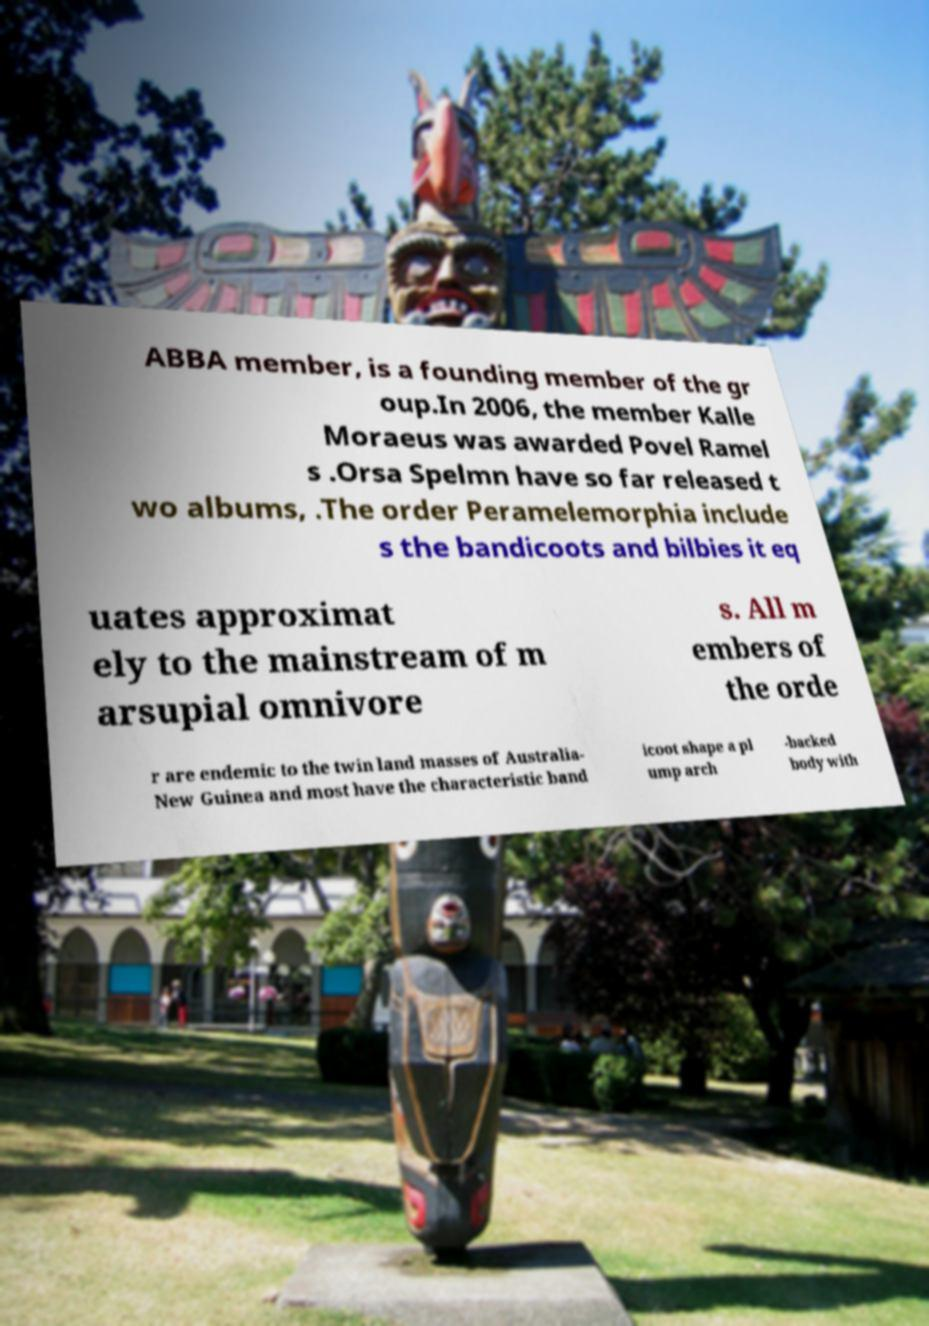Could you extract and type out the text from this image? ABBA member, is a founding member of the gr oup.In 2006, the member Kalle Moraeus was awarded Povel Ramel s .Orsa Spelmn have so far released t wo albums, .The order Peramelemorphia include s the bandicoots and bilbies it eq uates approximat ely to the mainstream of m arsupial omnivore s. All m embers of the orde r are endemic to the twin land masses of Australia- New Guinea and most have the characteristic band icoot shape a pl ump arch -backed body with 